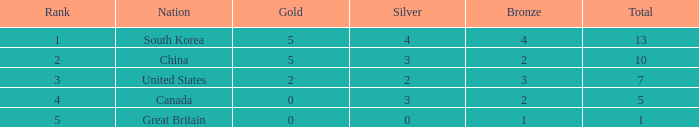What is the complete amount of gold, when silver is 2, and when the total is lesser than 7? 0.0. 